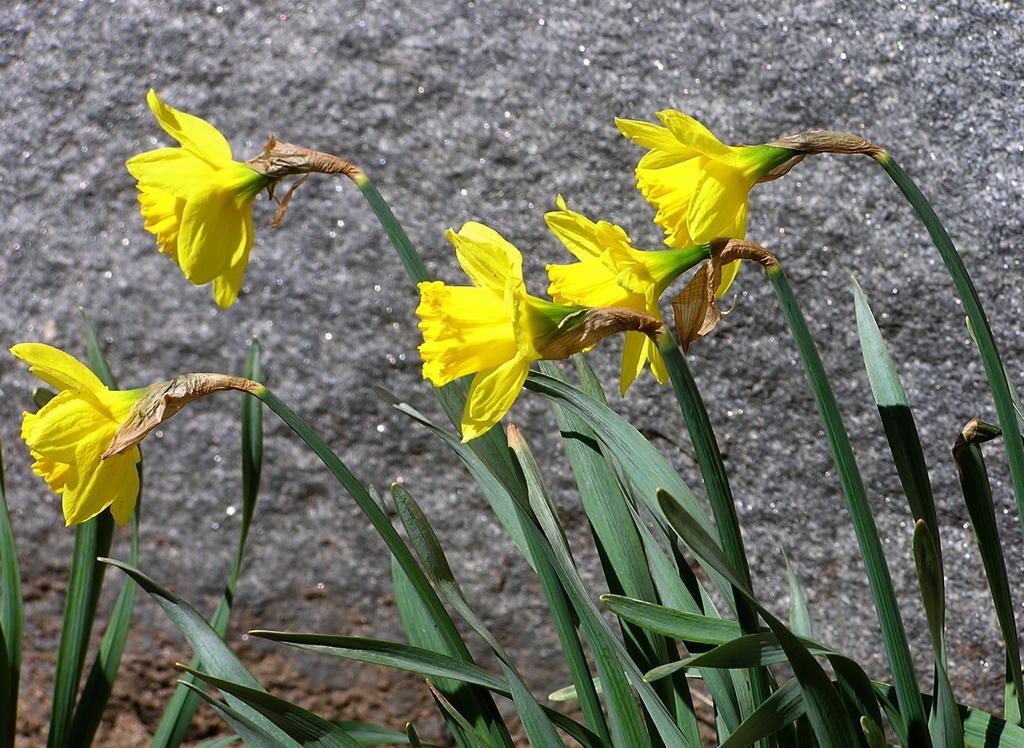Describe this image in one or two sentences. In this image there are some plants at bottom of this image and as we can see there are some yellow color flowers in middle of this image. 